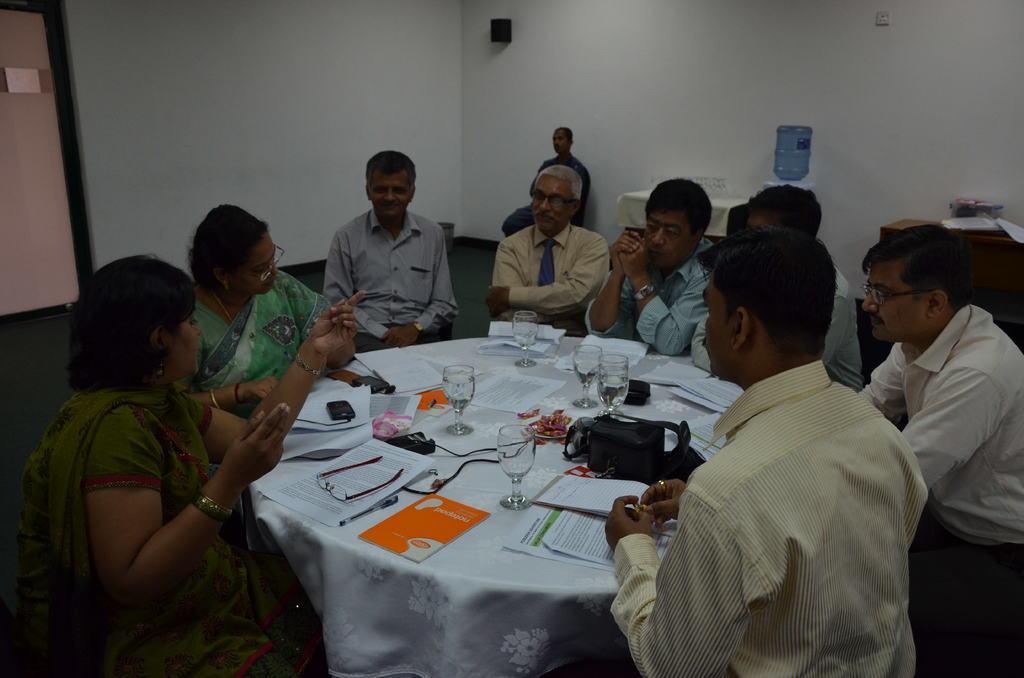How would you summarize this image in a sentence or two? The image is inside the room. In the image there are are group of people sitting on chair in front of a table, on table we can see a book,pen,paper,glasses,mobile,glass with some drink. On left side there is a pink color door and background we can see a wall which is in white color. 